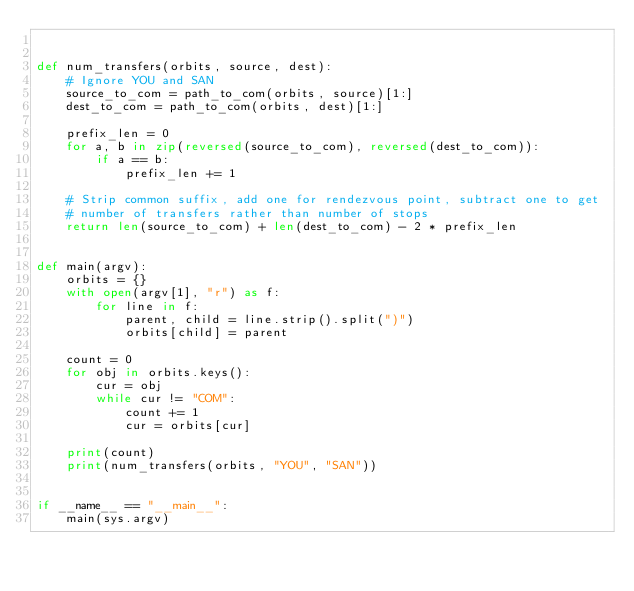<code> <loc_0><loc_0><loc_500><loc_500><_Python_>

def num_transfers(orbits, source, dest):
    # Ignore YOU and SAN
    source_to_com = path_to_com(orbits, source)[1:]
    dest_to_com = path_to_com(orbits, dest)[1:]

    prefix_len = 0
    for a, b in zip(reversed(source_to_com), reversed(dest_to_com)):
        if a == b:
            prefix_len += 1

    # Strip common suffix, add one for rendezvous point, subtract one to get
    # number of transfers rather than number of stops
    return len(source_to_com) + len(dest_to_com) - 2 * prefix_len


def main(argv):
    orbits = {}
    with open(argv[1], "r") as f:
        for line in f:
            parent, child = line.strip().split(")")
            orbits[child] = parent

    count = 0
    for obj in orbits.keys():
        cur = obj
        while cur != "COM":
            count += 1
            cur = orbits[cur]

    print(count)
    print(num_transfers(orbits, "YOU", "SAN"))


if __name__ == "__main__":
    main(sys.argv)
</code> 